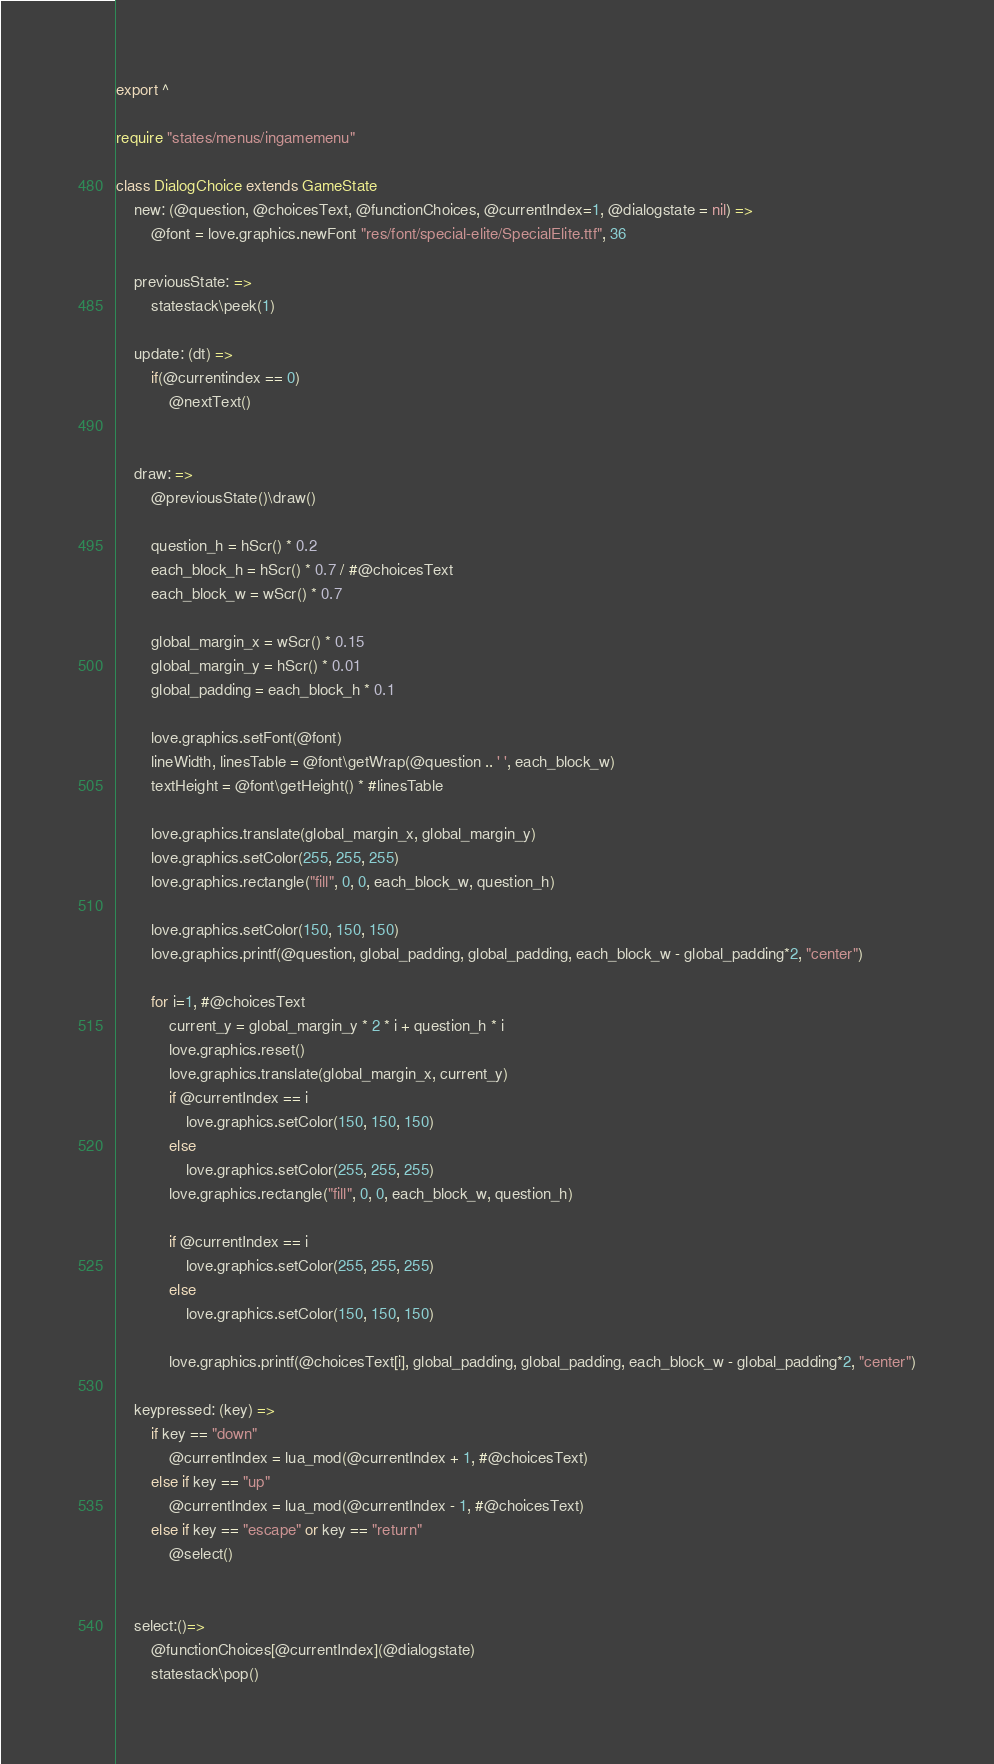<code> <loc_0><loc_0><loc_500><loc_500><_MoonScript_>export ^

require "states/menus/ingamemenu"

class DialogChoice extends GameState
    new: (@question, @choicesText, @functionChoices, @currentIndex=1, @dialogstate = nil) =>
        @font = love.graphics.newFont "res/font/special-elite/SpecialElite.ttf", 36

    previousState: =>
        statestack\peek(1)

    update: (dt) =>
        if(@currentindex == 0)
            @nextText()


    draw: =>
        @previousState()\draw()

        question_h = hScr() * 0.2
        each_block_h = hScr() * 0.7 / #@choicesText
        each_block_w = wScr() * 0.7

        global_margin_x = wScr() * 0.15
        global_margin_y = hScr() * 0.01
        global_padding = each_block_h * 0.1

        love.graphics.setFont(@font)
        lineWidth, linesTable = @font\getWrap(@question .. ' ', each_block_w)
        textHeight = @font\getHeight() * #linesTable

        love.graphics.translate(global_margin_x, global_margin_y)
        love.graphics.setColor(255, 255, 255)
        love.graphics.rectangle("fill", 0, 0, each_block_w, question_h)

        love.graphics.setColor(150, 150, 150)
        love.graphics.printf(@question, global_padding, global_padding, each_block_w - global_padding*2, "center")

        for i=1, #@choicesText
            current_y = global_margin_y * 2 * i + question_h * i
            love.graphics.reset()
            love.graphics.translate(global_margin_x, current_y)
            if @currentIndex == i
                love.graphics.setColor(150, 150, 150)
            else
                love.graphics.setColor(255, 255, 255)
            love.graphics.rectangle("fill", 0, 0, each_block_w, question_h)

            if @currentIndex == i
                love.graphics.setColor(255, 255, 255)
            else
                love.graphics.setColor(150, 150, 150)

            love.graphics.printf(@choicesText[i], global_padding, global_padding, each_block_w - global_padding*2, "center")

    keypressed: (key) =>
        if key == "down"
            @currentIndex = lua_mod(@currentIndex + 1, #@choicesText)
        else if key == "up"
            @currentIndex = lua_mod(@currentIndex - 1, #@choicesText)
        else if key == "escape" or key == "return"
            @select()


    select:()=>
        @functionChoices[@currentIndex](@dialogstate)
        statestack\pop()
</code> 